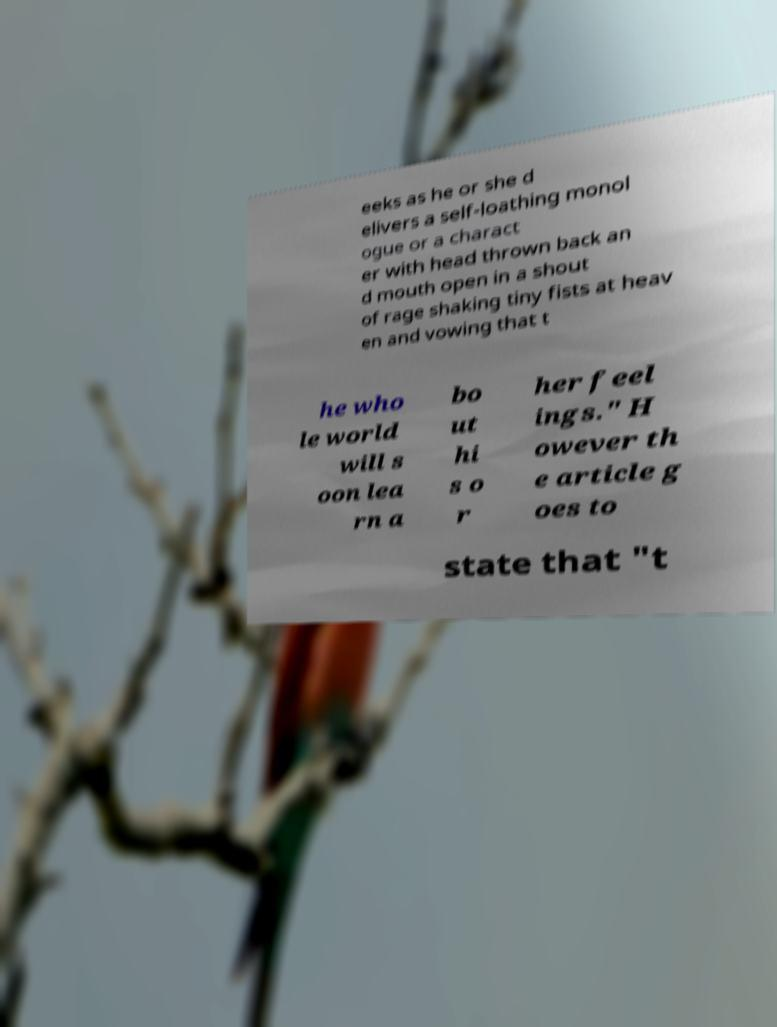Please read and relay the text visible in this image. What does it say? eeks as he or she d elivers a self-loathing monol ogue or a charact er with head thrown back an d mouth open in a shout of rage shaking tiny fists at heav en and vowing that t he who le world will s oon lea rn a bo ut hi s o r her feel ings." H owever th e article g oes to state that "t 